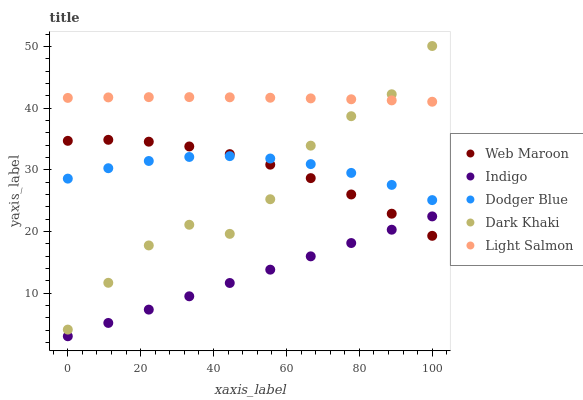Does Indigo have the minimum area under the curve?
Answer yes or no. Yes. Does Light Salmon have the maximum area under the curve?
Answer yes or no. Yes. Does Light Salmon have the minimum area under the curve?
Answer yes or no. No. Does Indigo have the maximum area under the curve?
Answer yes or no. No. Is Indigo the smoothest?
Answer yes or no. Yes. Is Dark Khaki the roughest?
Answer yes or no. Yes. Is Light Salmon the smoothest?
Answer yes or no. No. Is Light Salmon the roughest?
Answer yes or no. No. Does Indigo have the lowest value?
Answer yes or no. Yes. Does Light Salmon have the lowest value?
Answer yes or no. No. Does Dark Khaki have the highest value?
Answer yes or no. Yes. Does Light Salmon have the highest value?
Answer yes or no. No. Is Dodger Blue less than Light Salmon?
Answer yes or no. Yes. Is Light Salmon greater than Indigo?
Answer yes or no. Yes. Does Dark Khaki intersect Light Salmon?
Answer yes or no. Yes. Is Dark Khaki less than Light Salmon?
Answer yes or no. No. Is Dark Khaki greater than Light Salmon?
Answer yes or no. No. Does Dodger Blue intersect Light Salmon?
Answer yes or no. No. 